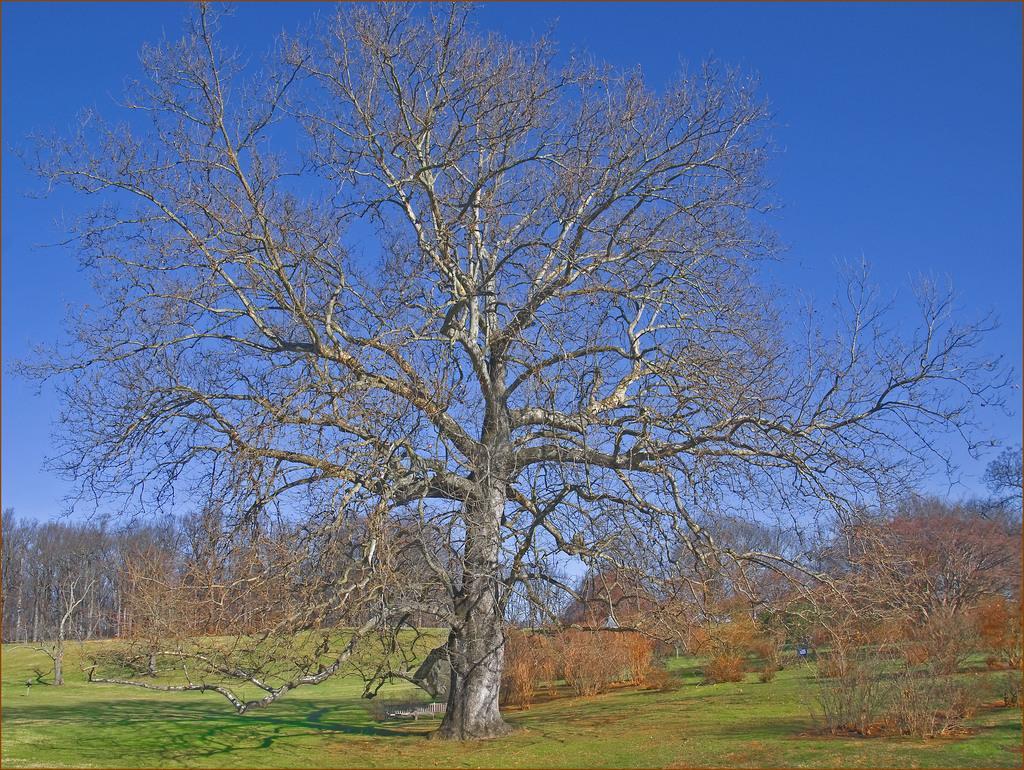In one or two sentences, can you explain what this image depicts? In this I can see the grass. In the background, I can see the trees and the sky. 